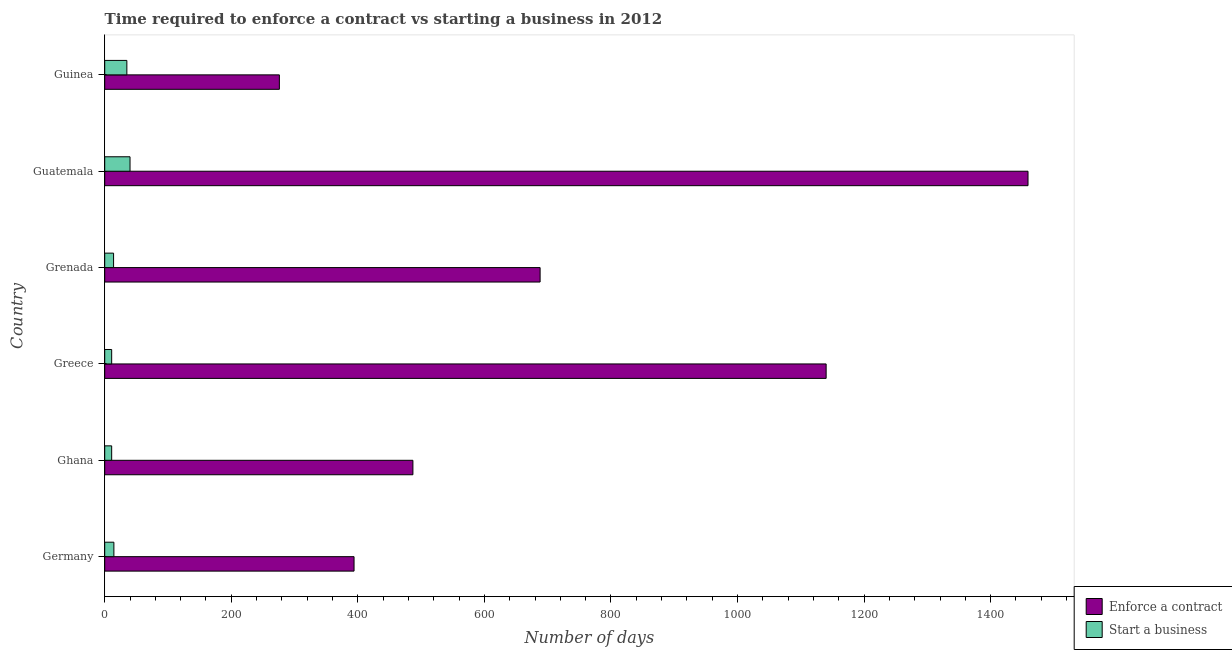How many groups of bars are there?
Your response must be concise. 6. Are the number of bars on each tick of the Y-axis equal?
Give a very brief answer. Yes. How many bars are there on the 2nd tick from the top?
Keep it short and to the point. 2. What is the label of the 1st group of bars from the top?
Offer a terse response. Guinea. What is the number of days to enforece a contract in Guinea?
Your answer should be compact. 276. In which country was the number of days to enforece a contract maximum?
Make the answer very short. Guatemala. In which country was the number of days to enforece a contract minimum?
Provide a succinct answer. Guinea. What is the total number of days to start a business in the graph?
Ensure brevity in your answer.  125.5. What is the difference between the number of days to enforece a contract in Greece and that in Grenada?
Make the answer very short. 452. What is the difference between the number of days to enforece a contract in Grenada and the number of days to start a business in Guinea?
Provide a succinct answer. 653. What is the average number of days to start a business per country?
Your answer should be compact. 20.92. What is the difference between the number of days to start a business and number of days to enforece a contract in Guatemala?
Keep it short and to the point. -1419. In how many countries, is the number of days to start a business greater than 1000 days?
Offer a very short reply. 0. What is the ratio of the number of days to start a business in Guatemala to that in Guinea?
Offer a terse response. 1.14. Is the number of days to enforece a contract in Grenada less than that in Guinea?
Provide a succinct answer. No. What is the difference between the highest and the second highest number of days to start a business?
Your answer should be compact. 5. What is the difference between the highest and the lowest number of days to start a business?
Your answer should be compact. 29. Is the sum of the number of days to enforece a contract in Guatemala and Guinea greater than the maximum number of days to start a business across all countries?
Your answer should be very brief. Yes. What does the 1st bar from the top in Guatemala represents?
Give a very brief answer. Start a business. What does the 1st bar from the bottom in Greece represents?
Ensure brevity in your answer.  Enforce a contract. How many bars are there?
Offer a terse response. 12. Are all the bars in the graph horizontal?
Provide a succinct answer. Yes. How many countries are there in the graph?
Provide a succinct answer. 6. Are the values on the major ticks of X-axis written in scientific E-notation?
Offer a terse response. No. How are the legend labels stacked?
Give a very brief answer. Vertical. What is the title of the graph?
Offer a very short reply. Time required to enforce a contract vs starting a business in 2012. What is the label or title of the X-axis?
Ensure brevity in your answer.  Number of days. What is the label or title of the Y-axis?
Your response must be concise. Country. What is the Number of days in Enforce a contract in Germany?
Offer a very short reply. 394. What is the Number of days in Enforce a contract in Ghana?
Ensure brevity in your answer.  487. What is the Number of days in Start a business in Ghana?
Offer a terse response. 11. What is the Number of days of Enforce a contract in Greece?
Ensure brevity in your answer.  1140. What is the Number of days of Enforce a contract in Grenada?
Provide a short and direct response. 688. What is the Number of days of Start a business in Grenada?
Keep it short and to the point. 14. What is the Number of days in Enforce a contract in Guatemala?
Your response must be concise. 1459. What is the Number of days of Start a business in Guatemala?
Ensure brevity in your answer.  40. What is the Number of days in Enforce a contract in Guinea?
Offer a terse response. 276. Across all countries, what is the maximum Number of days of Enforce a contract?
Your answer should be very brief. 1459. Across all countries, what is the maximum Number of days of Start a business?
Your answer should be very brief. 40. Across all countries, what is the minimum Number of days of Enforce a contract?
Ensure brevity in your answer.  276. Across all countries, what is the minimum Number of days of Start a business?
Offer a very short reply. 11. What is the total Number of days in Enforce a contract in the graph?
Offer a very short reply. 4444. What is the total Number of days of Start a business in the graph?
Your response must be concise. 125.5. What is the difference between the Number of days of Enforce a contract in Germany and that in Ghana?
Your answer should be compact. -93. What is the difference between the Number of days in Enforce a contract in Germany and that in Greece?
Offer a very short reply. -746. What is the difference between the Number of days of Start a business in Germany and that in Greece?
Keep it short and to the point. 3.5. What is the difference between the Number of days of Enforce a contract in Germany and that in Grenada?
Give a very brief answer. -294. What is the difference between the Number of days of Start a business in Germany and that in Grenada?
Offer a very short reply. 0.5. What is the difference between the Number of days of Enforce a contract in Germany and that in Guatemala?
Your answer should be compact. -1065. What is the difference between the Number of days of Start a business in Germany and that in Guatemala?
Your response must be concise. -25.5. What is the difference between the Number of days of Enforce a contract in Germany and that in Guinea?
Your answer should be compact. 118. What is the difference between the Number of days of Start a business in Germany and that in Guinea?
Provide a short and direct response. -20.5. What is the difference between the Number of days of Enforce a contract in Ghana and that in Greece?
Offer a very short reply. -653. What is the difference between the Number of days in Start a business in Ghana and that in Greece?
Ensure brevity in your answer.  0. What is the difference between the Number of days of Enforce a contract in Ghana and that in Grenada?
Make the answer very short. -201. What is the difference between the Number of days in Enforce a contract in Ghana and that in Guatemala?
Offer a terse response. -972. What is the difference between the Number of days in Start a business in Ghana and that in Guatemala?
Provide a short and direct response. -29. What is the difference between the Number of days of Enforce a contract in Ghana and that in Guinea?
Offer a terse response. 211. What is the difference between the Number of days in Enforce a contract in Greece and that in Grenada?
Give a very brief answer. 452. What is the difference between the Number of days in Start a business in Greece and that in Grenada?
Keep it short and to the point. -3. What is the difference between the Number of days of Enforce a contract in Greece and that in Guatemala?
Your answer should be very brief. -319. What is the difference between the Number of days of Enforce a contract in Greece and that in Guinea?
Provide a succinct answer. 864. What is the difference between the Number of days of Enforce a contract in Grenada and that in Guatemala?
Your answer should be compact. -771. What is the difference between the Number of days of Enforce a contract in Grenada and that in Guinea?
Offer a very short reply. 412. What is the difference between the Number of days in Enforce a contract in Guatemala and that in Guinea?
Your answer should be very brief. 1183. What is the difference between the Number of days in Enforce a contract in Germany and the Number of days in Start a business in Ghana?
Your response must be concise. 383. What is the difference between the Number of days of Enforce a contract in Germany and the Number of days of Start a business in Greece?
Provide a succinct answer. 383. What is the difference between the Number of days of Enforce a contract in Germany and the Number of days of Start a business in Grenada?
Your answer should be compact. 380. What is the difference between the Number of days of Enforce a contract in Germany and the Number of days of Start a business in Guatemala?
Give a very brief answer. 354. What is the difference between the Number of days of Enforce a contract in Germany and the Number of days of Start a business in Guinea?
Give a very brief answer. 359. What is the difference between the Number of days in Enforce a contract in Ghana and the Number of days in Start a business in Greece?
Give a very brief answer. 476. What is the difference between the Number of days in Enforce a contract in Ghana and the Number of days in Start a business in Grenada?
Your answer should be compact. 473. What is the difference between the Number of days in Enforce a contract in Ghana and the Number of days in Start a business in Guatemala?
Your answer should be very brief. 447. What is the difference between the Number of days in Enforce a contract in Ghana and the Number of days in Start a business in Guinea?
Your answer should be very brief. 452. What is the difference between the Number of days in Enforce a contract in Greece and the Number of days in Start a business in Grenada?
Provide a short and direct response. 1126. What is the difference between the Number of days of Enforce a contract in Greece and the Number of days of Start a business in Guatemala?
Provide a short and direct response. 1100. What is the difference between the Number of days of Enforce a contract in Greece and the Number of days of Start a business in Guinea?
Your answer should be compact. 1105. What is the difference between the Number of days in Enforce a contract in Grenada and the Number of days in Start a business in Guatemala?
Offer a very short reply. 648. What is the difference between the Number of days in Enforce a contract in Grenada and the Number of days in Start a business in Guinea?
Make the answer very short. 653. What is the difference between the Number of days in Enforce a contract in Guatemala and the Number of days in Start a business in Guinea?
Ensure brevity in your answer.  1424. What is the average Number of days in Enforce a contract per country?
Make the answer very short. 740.67. What is the average Number of days in Start a business per country?
Offer a very short reply. 20.92. What is the difference between the Number of days in Enforce a contract and Number of days in Start a business in Germany?
Make the answer very short. 379.5. What is the difference between the Number of days in Enforce a contract and Number of days in Start a business in Ghana?
Your answer should be very brief. 476. What is the difference between the Number of days of Enforce a contract and Number of days of Start a business in Greece?
Keep it short and to the point. 1129. What is the difference between the Number of days of Enforce a contract and Number of days of Start a business in Grenada?
Provide a succinct answer. 674. What is the difference between the Number of days of Enforce a contract and Number of days of Start a business in Guatemala?
Offer a very short reply. 1419. What is the difference between the Number of days of Enforce a contract and Number of days of Start a business in Guinea?
Make the answer very short. 241. What is the ratio of the Number of days in Enforce a contract in Germany to that in Ghana?
Keep it short and to the point. 0.81. What is the ratio of the Number of days of Start a business in Germany to that in Ghana?
Make the answer very short. 1.32. What is the ratio of the Number of days in Enforce a contract in Germany to that in Greece?
Your answer should be very brief. 0.35. What is the ratio of the Number of days of Start a business in Germany to that in Greece?
Offer a terse response. 1.32. What is the ratio of the Number of days of Enforce a contract in Germany to that in Grenada?
Provide a short and direct response. 0.57. What is the ratio of the Number of days of Start a business in Germany to that in Grenada?
Your answer should be compact. 1.04. What is the ratio of the Number of days of Enforce a contract in Germany to that in Guatemala?
Ensure brevity in your answer.  0.27. What is the ratio of the Number of days of Start a business in Germany to that in Guatemala?
Provide a short and direct response. 0.36. What is the ratio of the Number of days of Enforce a contract in Germany to that in Guinea?
Your answer should be compact. 1.43. What is the ratio of the Number of days of Start a business in Germany to that in Guinea?
Offer a terse response. 0.41. What is the ratio of the Number of days in Enforce a contract in Ghana to that in Greece?
Make the answer very short. 0.43. What is the ratio of the Number of days in Enforce a contract in Ghana to that in Grenada?
Your answer should be compact. 0.71. What is the ratio of the Number of days of Start a business in Ghana to that in Grenada?
Make the answer very short. 0.79. What is the ratio of the Number of days of Enforce a contract in Ghana to that in Guatemala?
Keep it short and to the point. 0.33. What is the ratio of the Number of days of Start a business in Ghana to that in Guatemala?
Provide a short and direct response. 0.28. What is the ratio of the Number of days of Enforce a contract in Ghana to that in Guinea?
Give a very brief answer. 1.76. What is the ratio of the Number of days of Start a business in Ghana to that in Guinea?
Make the answer very short. 0.31. What is the ratio of the Number of days in Enforce a contract in Greece to that in Grenada?
Your response must be concise. 1.66. What is the ratio of the Number of days of Start a business in Greece to that in Grenada?
Make the answer very short. 0.79. What is the ratio of the Number of days in Enforce a contract in Greece to that in Guatemala?
Your answer should be very brief. 0.78. What is the ratio of the Number of days in Start a business in Greece to that in Guatemala?
Provide a succinct answer. 0.28. What is the ratio of the Number of days of Enforce a contract in Greece to that in Guinea?
Make the answer very short. 4.13. What is the ratio of the Number of days of Start a business in Greece to that in Guinea?
Keep it short and to the point. 0.31. What is the ratio of the Number of days in Enforce a contract in Grenada to that in Guatemala?
Ensure brevity in your answer.  0.47. What is the ratio of the Number of days of Start a business in Grenada to that in Guatemala?
Your response must be concise. 0.35. What is the ratio of the Number of days of Enforce a contract in Grenada to that in Guinea?
Provide a succinct answer. 2.49. What is the ratio of the Number of days in Start a business in Grenada to that in Guinea?
Offer a very short reply. 0.4. What is the ratio of the Number of days of Enforce a contract in Guatemala to that in Guinea?
Give a very brief answer. 5.29. What is the ratio of the Number of days of Start a business in Guatemala to that in Guinea?
Ensure brevity in your answer.  1.14. What is the difference between the highest and the second highest Number of days in Enforce a contract?
Make the answer very short. 319. What is the difference between the highest and the second highest Number of days in Start a business?
Offer a very short reply. 5. What is the difference between the highest and the lowest Number of days of Enforce a contract?
Offer a terse response. 1183. What is the difference between the highest and the lowest Number of days of Start a business?
Keep it short and to the point. 29. 